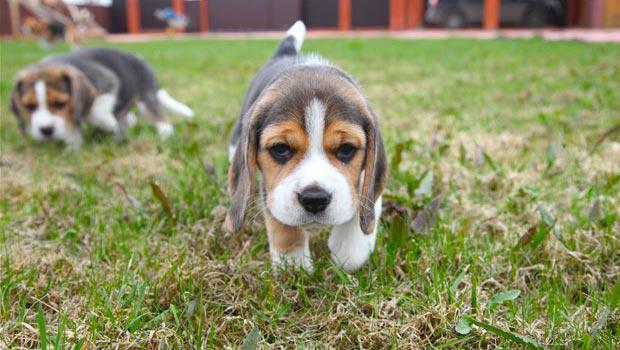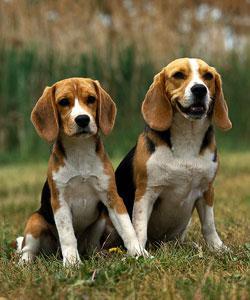The first image is the image on the left, the second image is the image on the right. For the images displayed, is the sentence "Two camera-facing beagles of similar size and coloring sit upright in the grass, and neither are young puppies." factually correct? Answer yes or no. Yes. The first image is the image on the left, the second image is the image on the right. Considering the images on both sides, is "There are exactly four dogs, and at least two of them seem to be puppies." valid? Answer yes or no. Yes. 